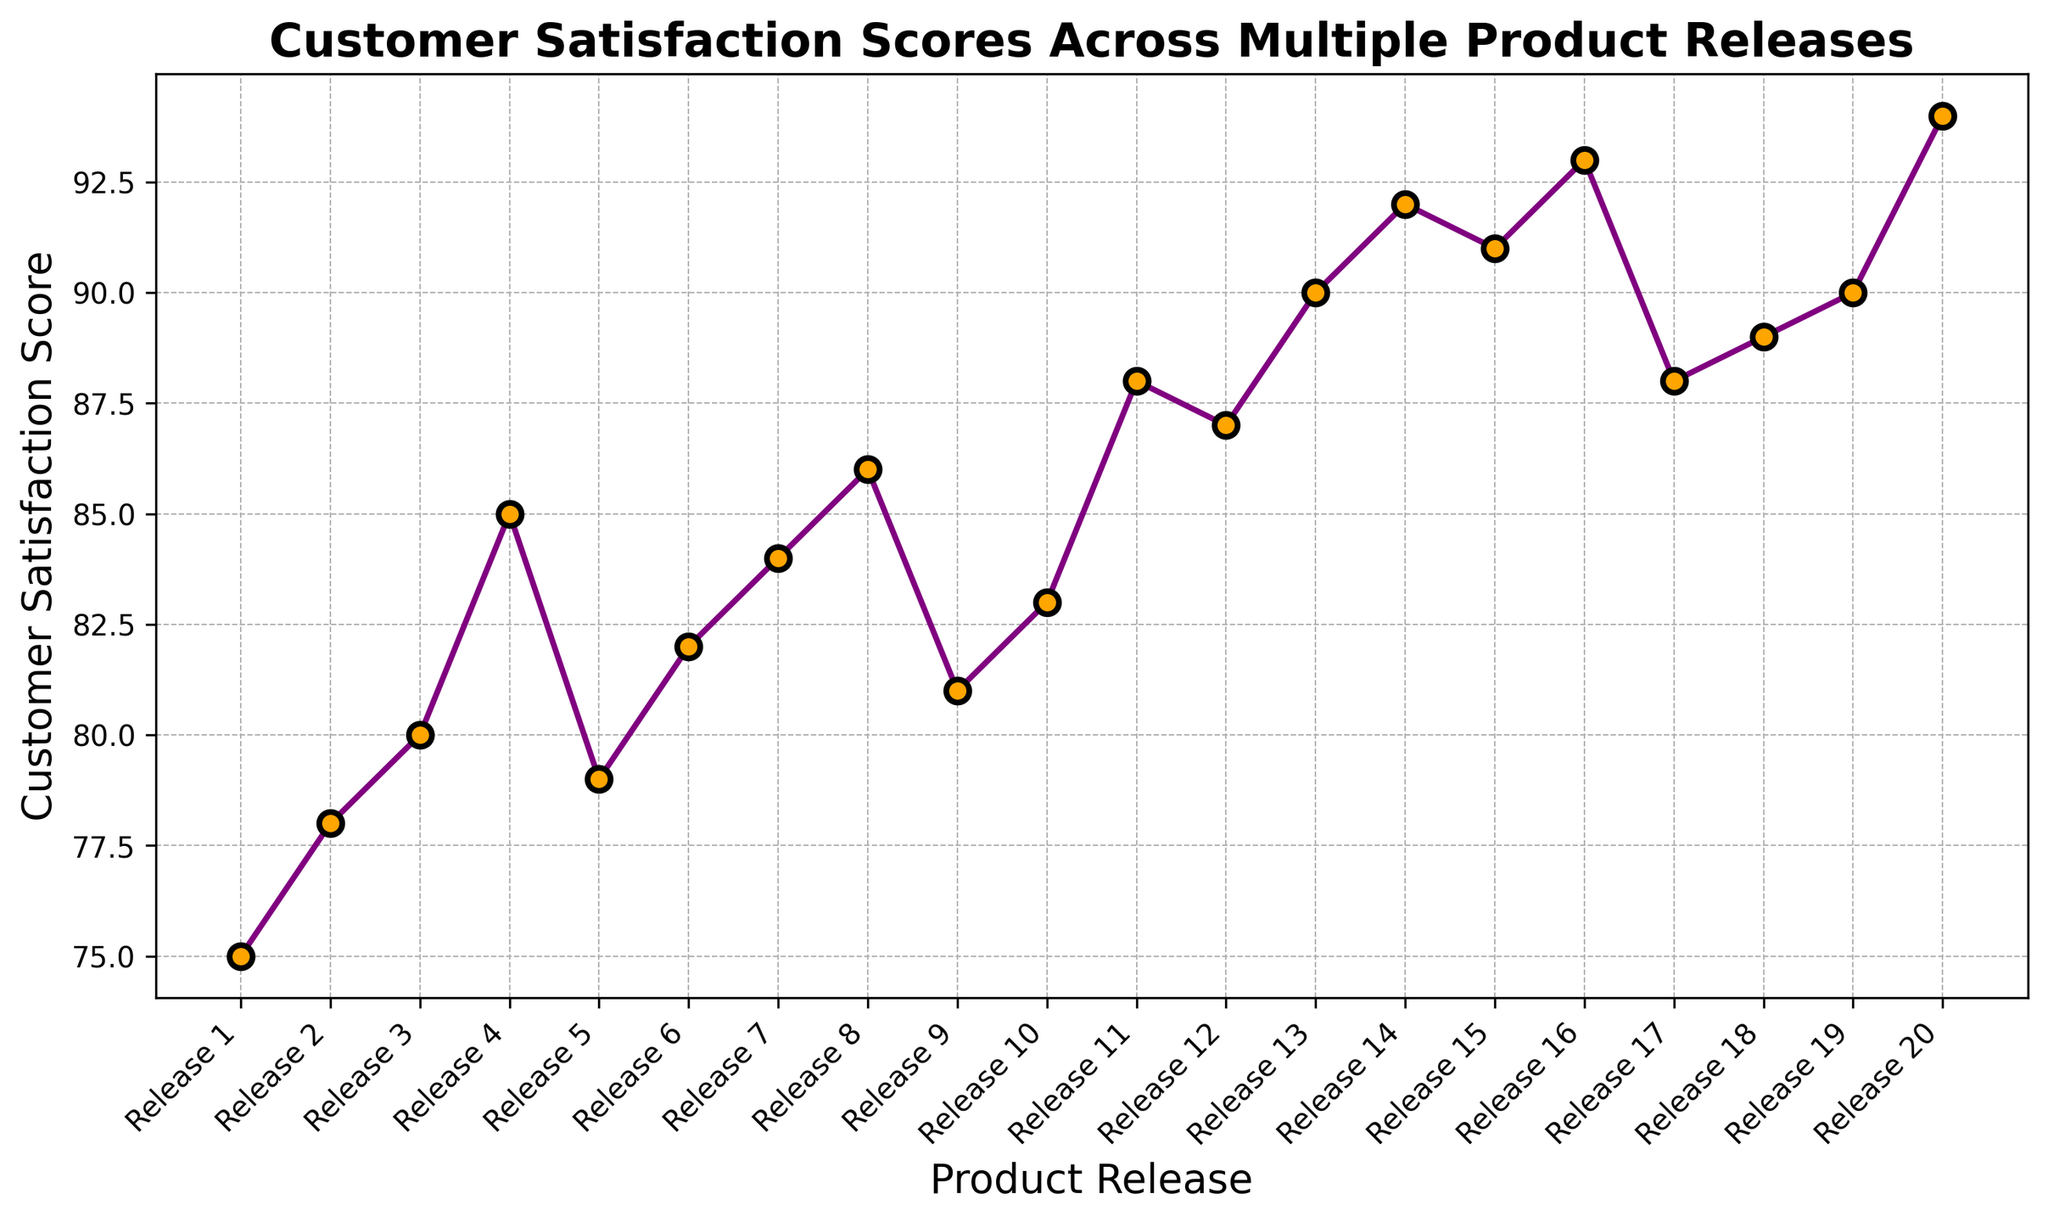What is the highest Customer Satisfaction Score across all product releases? The highest point on the line chart represents the peak score. Observing the highest point, we see that Release 20 has a Customer Satisfaction Score of 94.
Answer: 94 How does the Customer Satisfaction Score of Release 5 compare to Release 1? Checking the line chart, Release 1 has a score of 75, and Release 5 has a score of 79. Since 79 is greater than 75, Release 5 has a higher Customer Satisfaction Score than Release 1.
Answer: Release 5 is higher Across how many product releases did the Customer Satisfaction Score improve compared to the previous release? To determine this, we count the number of times the score rises from one release to the next by checking the slope direction between consecutive points in the line chart. The score increased 13 times between the releases.
Answer: 13 What is the average Customer Satisfaction Score for the first 10 product releases? Sum the scores of the first 10 releases (75 + 78 + 80 + 85 + 79 + 82 + 84 + 86 + 81 + 83) and then divide by 10. The total sum is 813, so the average is 813/10 = 81.3.
Answer: 81.3 Which product release had a significant drop in Customer Satisfaction Score compared to its previous release, and by how much? Observing the line chart, the most significant drop is between Release 16 (93) and Release 17 (88). The difference is calculated as 93 - 88 = 5.
Answer: Release 17, 5 points Between which two consecutive releases was the increase in Customer Satisfaction Score the greatest, and what was the increase? Check the differences between consecutive releases and identify the largest increase. The largest jump is from Release 3 (80) to Release 4 (85), which shows an increase of 85 - 80 = 5.
Answer: Release 3 to Release 4, 5 points What visual attributes are used to highlight the data points in the chart? Observing the chart, the data points are marked with orange circles that have black edges. These attributes make the points stand out along the line graph.
Answer: Orange circles with black edges What is the median Customer Satisfaction Score across all product releases? To find the median, list all scores in order (75, 78, 79, 80, 81, 82, 83, 84, 85, 86, 87, 88, 88, 89, 90, 90, 91, 92, 93, 94) and find the middle value. With 20 total releases, the median is the average of the 10th and 11th values: (83 + 87)/2 = 85.
Answer: 85 